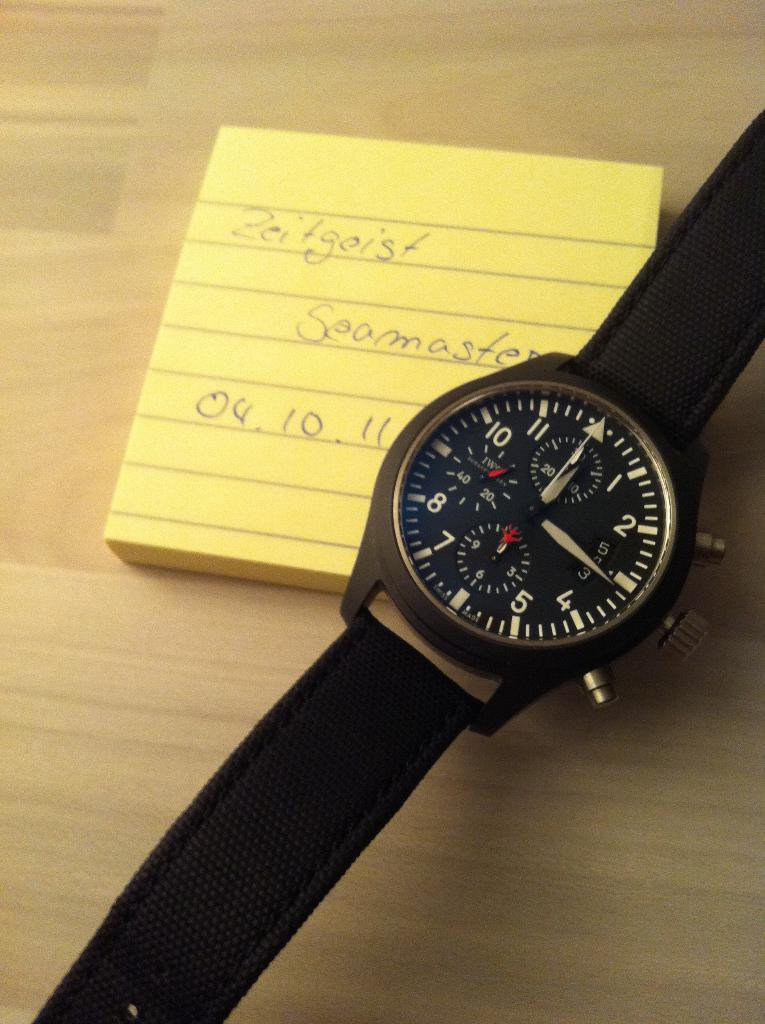Provide a one-sentence caption for the provided image. A wristwatch with a note saying Zeitgeist under it. 